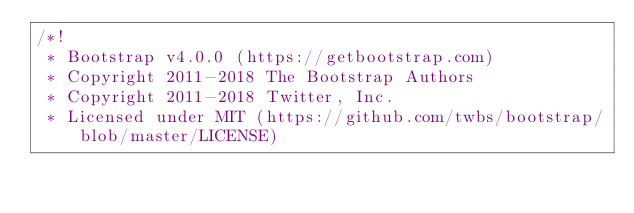<code> <loc_0><loc_0><loc_500><loc_500><_CSS_>/*!
 * Bootstrap v4.0.0 (https://getbootstrap.com)
 * Copyright 2011-2018 The Bootstrap Authors
 * Copyright 2011-2018 Twitter, Inc.
 * Licensed under MIT (https://github.com/twbs/bootstrap/blob/master/LICENSE)</code> 